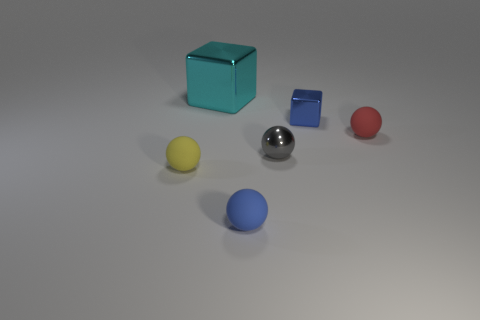There is a tiny thing that is both on the right side of the blue sphere and in front of the tiny red sphere; what is its material?
Ensure brevity in your answer.  Metal. What is the color of the object that is both in front of the big metallic thing and behind the small red rubber object?
Keep it short and to the point. Blue. Is there any other thing that is the same color as the shiny sphere?
Provide a succinct answer. No. What shape is the small object on the left side of the metallic thing behind the small blue object that is behind the tiny blue rubber sphere?
Your answer should be compact. Sphere. There is another tiny metallic thing that is the same shape as the tiny yellow thing; what is its color?
Your answer should be compact. Gray. What is the color of the tiny shiny thing in front of the small matte object on the right side of the tiny cube?
Offer a terse response. Gray. The blue matte thing that is the same shape as the tiny gray thing is what size?
Keep it short and to the point. Small. What number of cyan cubes are the same material as the cyan object?
Your answer should be compact. 0. How many big metallic cubes are on the right side of the small blue thing on the left side of the blue shiny cube?
Ensure brevity in your answer.  0. Are there any tiny cubes left of the blue matte object?
Offer a terse response. No. 